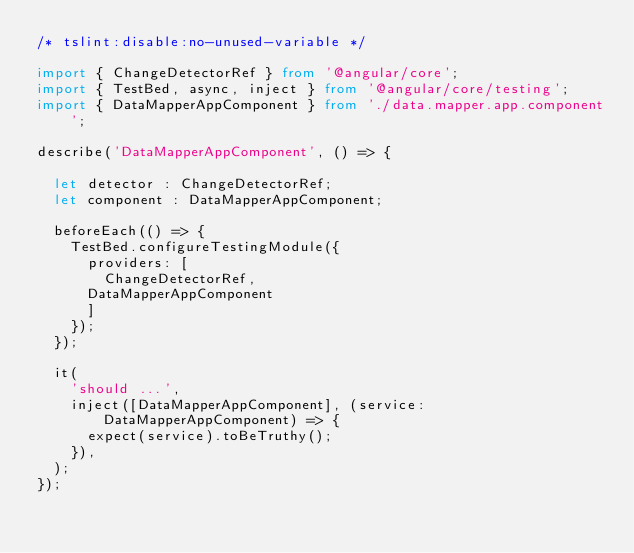<code> <loc_0><loc_0><loc_500><loc_500><_TypeScript_>/* tslint:disable:no-unused-variable */

import { ChangeDetectorRef } from '@angular/core';
import { TestBed, async, inject } from '@angular/core/testing';
import { DataMapperAppComponent } from './data.mapper.app.component';

describe('DataMapperAppComponent', () => {

  let detector : ChangeDetectorRef;
  let component : DataMapperAppComponent;

  beforeEach(() => {
    TestBed.configureTestingModule({
      providers: [
        ChangeDetectorRef,
      DataMapperAppComponent
      ]
    });
  });

  it(
    'should ...',
    inject([DataMapperAppComponent], (service: DataMapperAppComponent) => {
      expect(service).toBeTruthy();
    }),
  );
});
</code> 